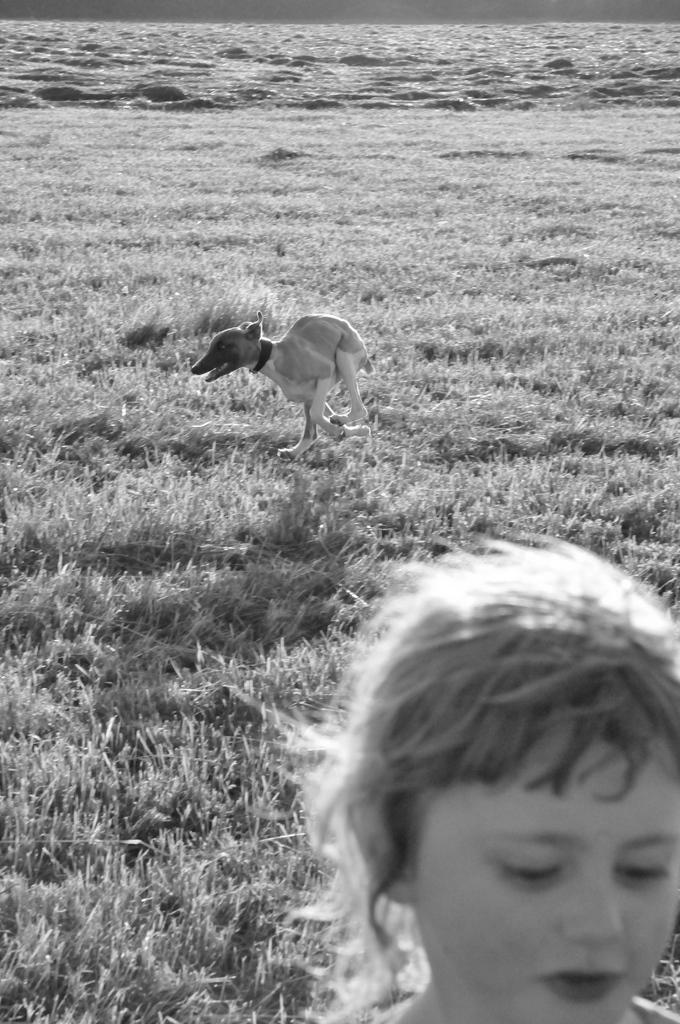What is the color scheme of the image? The image is black and white. What can be seen in the foreground of the image? There is a child's face and a dog on the grass in the image. What type of vegetation is visible in the image? The grass is visible in the image. What is in the background of the image? There is a river in the background of the image. What type of fuel is being used by the child in the image? There is no indication in the image that the child is using any type of fuel. What shape is the dog in the image? The dog is not a shape; it is a living creature. The image shows a dog on the grass, but it does not provide information about its shape. 